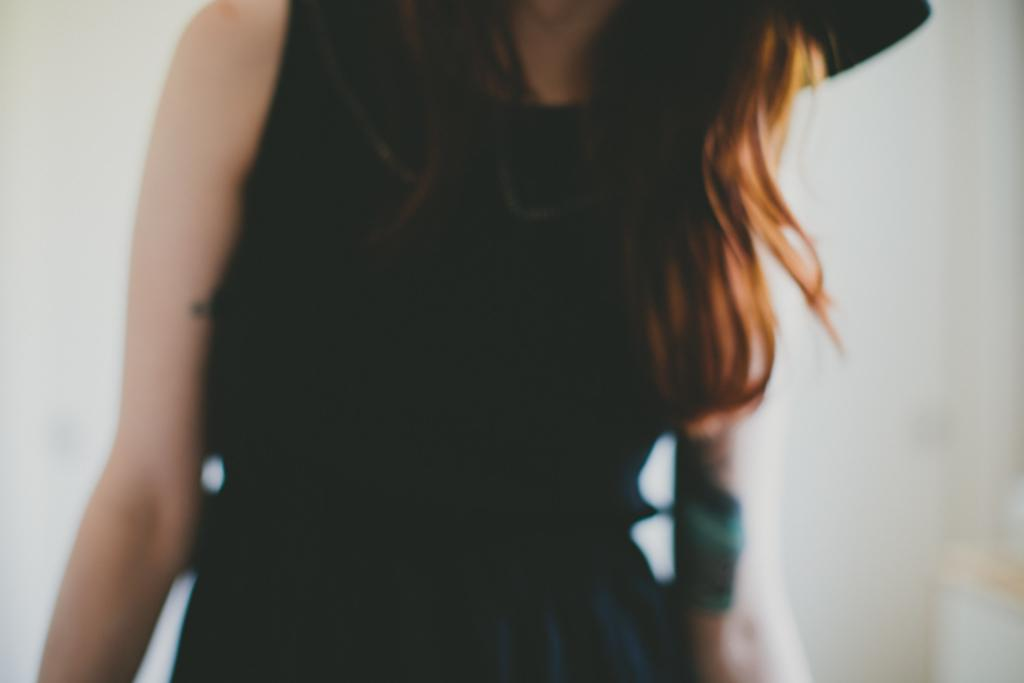What is the main subject of the image? The main subject of the image is a woman. What is the woman wearing in the image? The woman is wearing a black dress in the image. What type of mark can be seen on the woman's forehead in the image? There is no mark visible on the woman's forehead in the image. What kind of waves can be seen in the background of the image? There is no background or any waves present in the image; it only features a woman wearing a black dress. 